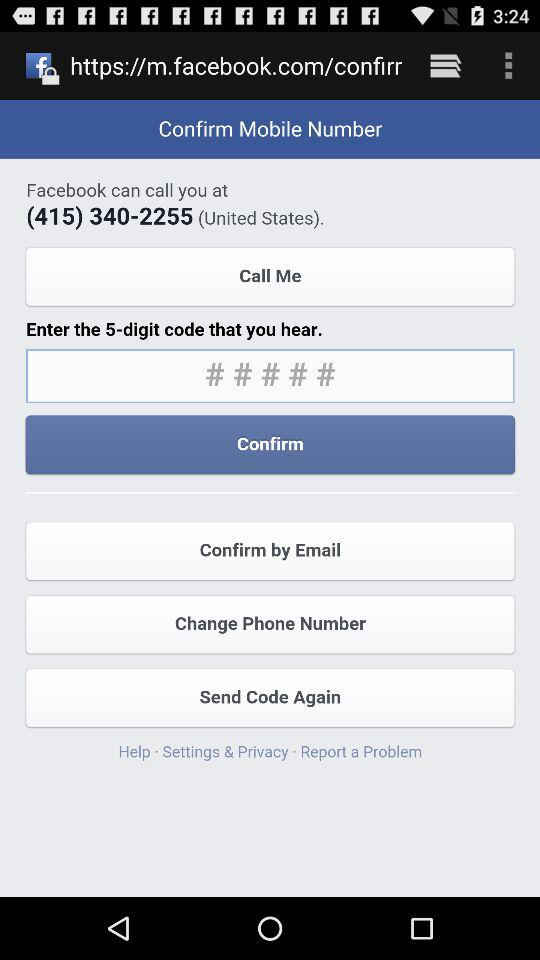What is the given phone number? The given phone number is (415) 340-2255. 